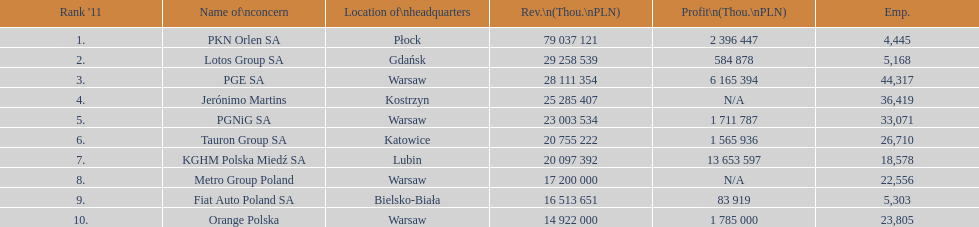What company is the only one with a revenue greater than 75,000,000 thou. pln? PKN Orlen SA. 